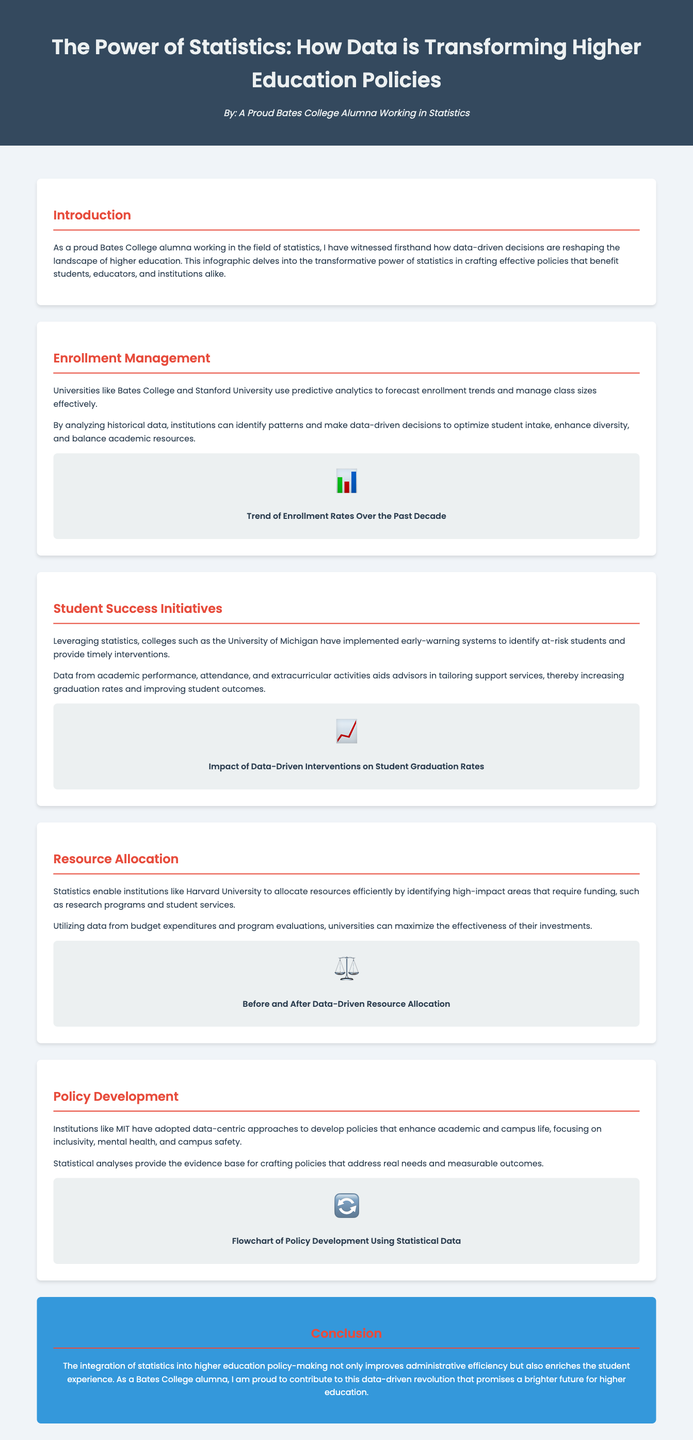What is the main theme of the infographic? The main theme is about how statistics are transforming higher education policies.
Answer: transforming higher education policies Which university uses predictive analytics for enrollment management? The document mentions that Bates College and Stanford University utilize predictive analytics for this purpose.
Answer: Bates College and Stanford University What kind of system has the University of Michigan implemented? The University of Michigan has implemented early-warning systems to help at-risk students.
Answer: early-warning systems What is the impact of data-driven interventions mentioned in the document? The impact refers to the improvements in student graduation rates due to the initiatives.
Answer: student graduation rates Which institution allocates resources efficiently using statistics? Harvard University is highlighted for its efficient use of statistics in resource allocation.
Answer: Harvard University What specific policy development focus does MIT emphasize? MIT focuses on inclusivity, mental health, and campus safety in its policy development.
Answer: inclusivity, mental health, campus safety What do statistical analyses provide for crafting policies? Statistical analyses provide the evidence base necessary for developing policies that address real needs.
Answer: evidence base How many key areas does the document cover regarding the power of statistics? The document covers four key areas: Enrollment Management, Student Success Initiatives, Resource Allocation, and Policy Development.
Answer: four key areas 